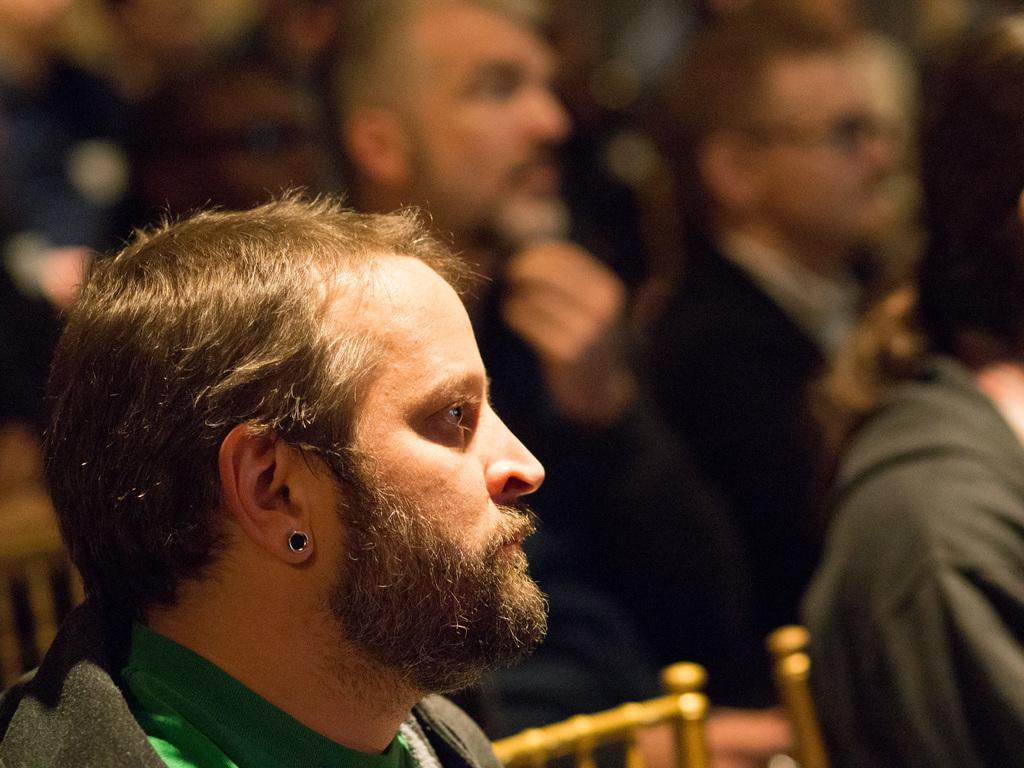In one or two sentences, can you explain what this image depicts? In this image there are a group of people who are sitting on chairs. 